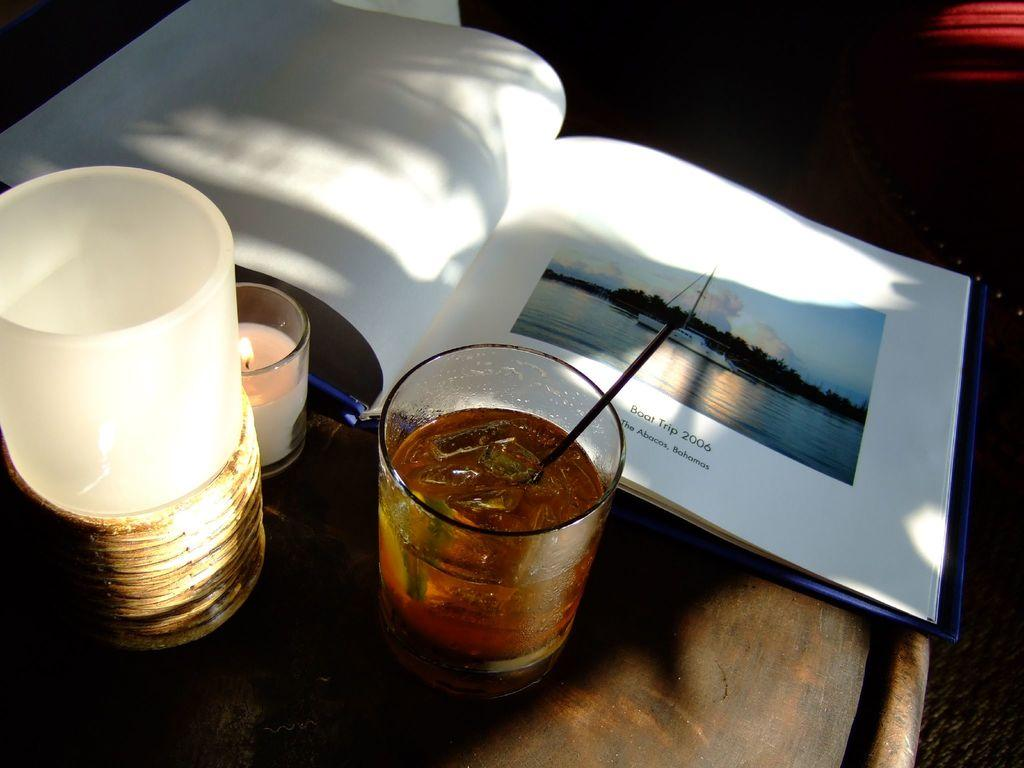Provide a one-sentence caption for the provided image. An album opened up to a page for a boat trip that was taken to the Bahamas is on a table next to a drink and a candle. 